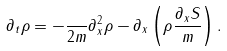Convert formula to latex. <formula><loc_0><loc_0><loc_500><loc_500>\partial _ { t } \rho = - \frac { } { 2 m } \partial _ { x } ^ { 2 } \rho - \partial _ { x } \left ( \rho \frac { \partial _ { x } S } { m } \right ) .</formula> 